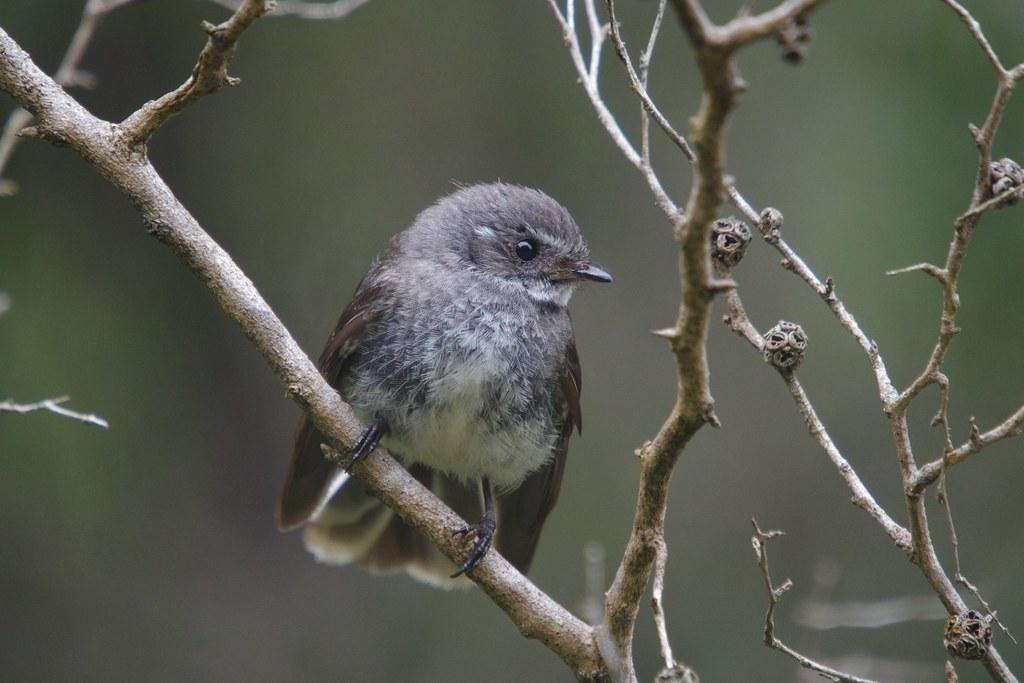What type of animal can be seen in the image? There is a bird in the image. Can you describe the colors of the bird? The bird has brown, ash, cream, and black colors. Where is the bird located in the image? The bird is standing on a tree branch. What color is the tree branch? The tree branch is brown in color. How would you describe the background of the image? The background of the image is blurry. What impulse does the bird have to fly in the image? There is no indication of the bird's impulse to fly in the image, as it is standing on a tree branch. How does the bird's self-awareness affect its behavior in the image? There is no information about the bird's self-awareness in the image, so it cannot be determined how it affects its behavior. 